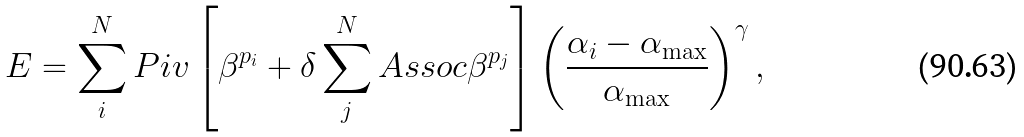Convert formula to latex. <formula><loc_0><loc_0><loc_500><loc_500>E = \sum _ { i } ^ { N } P i v \left [ \beta ^ { p _ { i } } + \delta \sum _ { j } ^ { N } A s s o c \beta ^ { p _ { j } } \right ] \left ( \frac { \alpha _ { i } - \alpha _ { \max } } { \alpha _ { \max } } \right ) ^ { \gamma } ,</formula> 